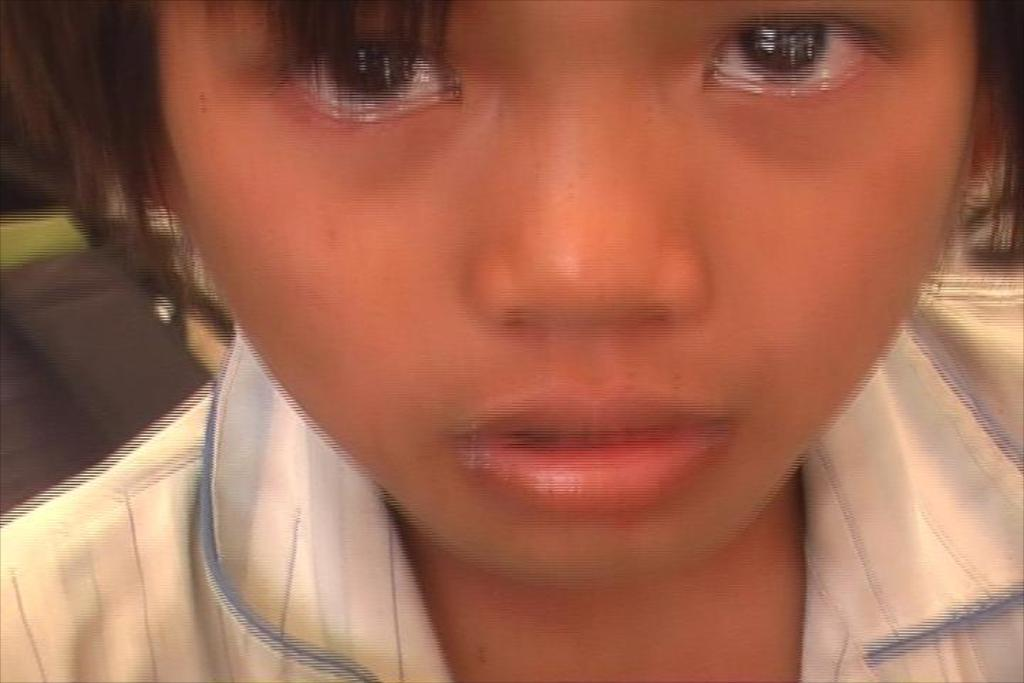What is the main subject of the image? The main subject of the image is a kid. What is the kid doing in the image? The kid is crying in the image. Where is the kid located in the image? The kid is in the center of the image. What type of toad can be seen holding a rose in the image? There is no toad or rose present in the image; it features a kid who is crying. What type of argument is the kid having with another person in the image? There is no indication of an argument or another person in the image; it only shows a kid who is crying. 